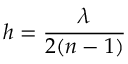Convert formula to latex. <formula><loc_0><loc_0><loc_500><loc_500>h = \frac { \lambda } { 2 ( n - 1 ) }</formula> 